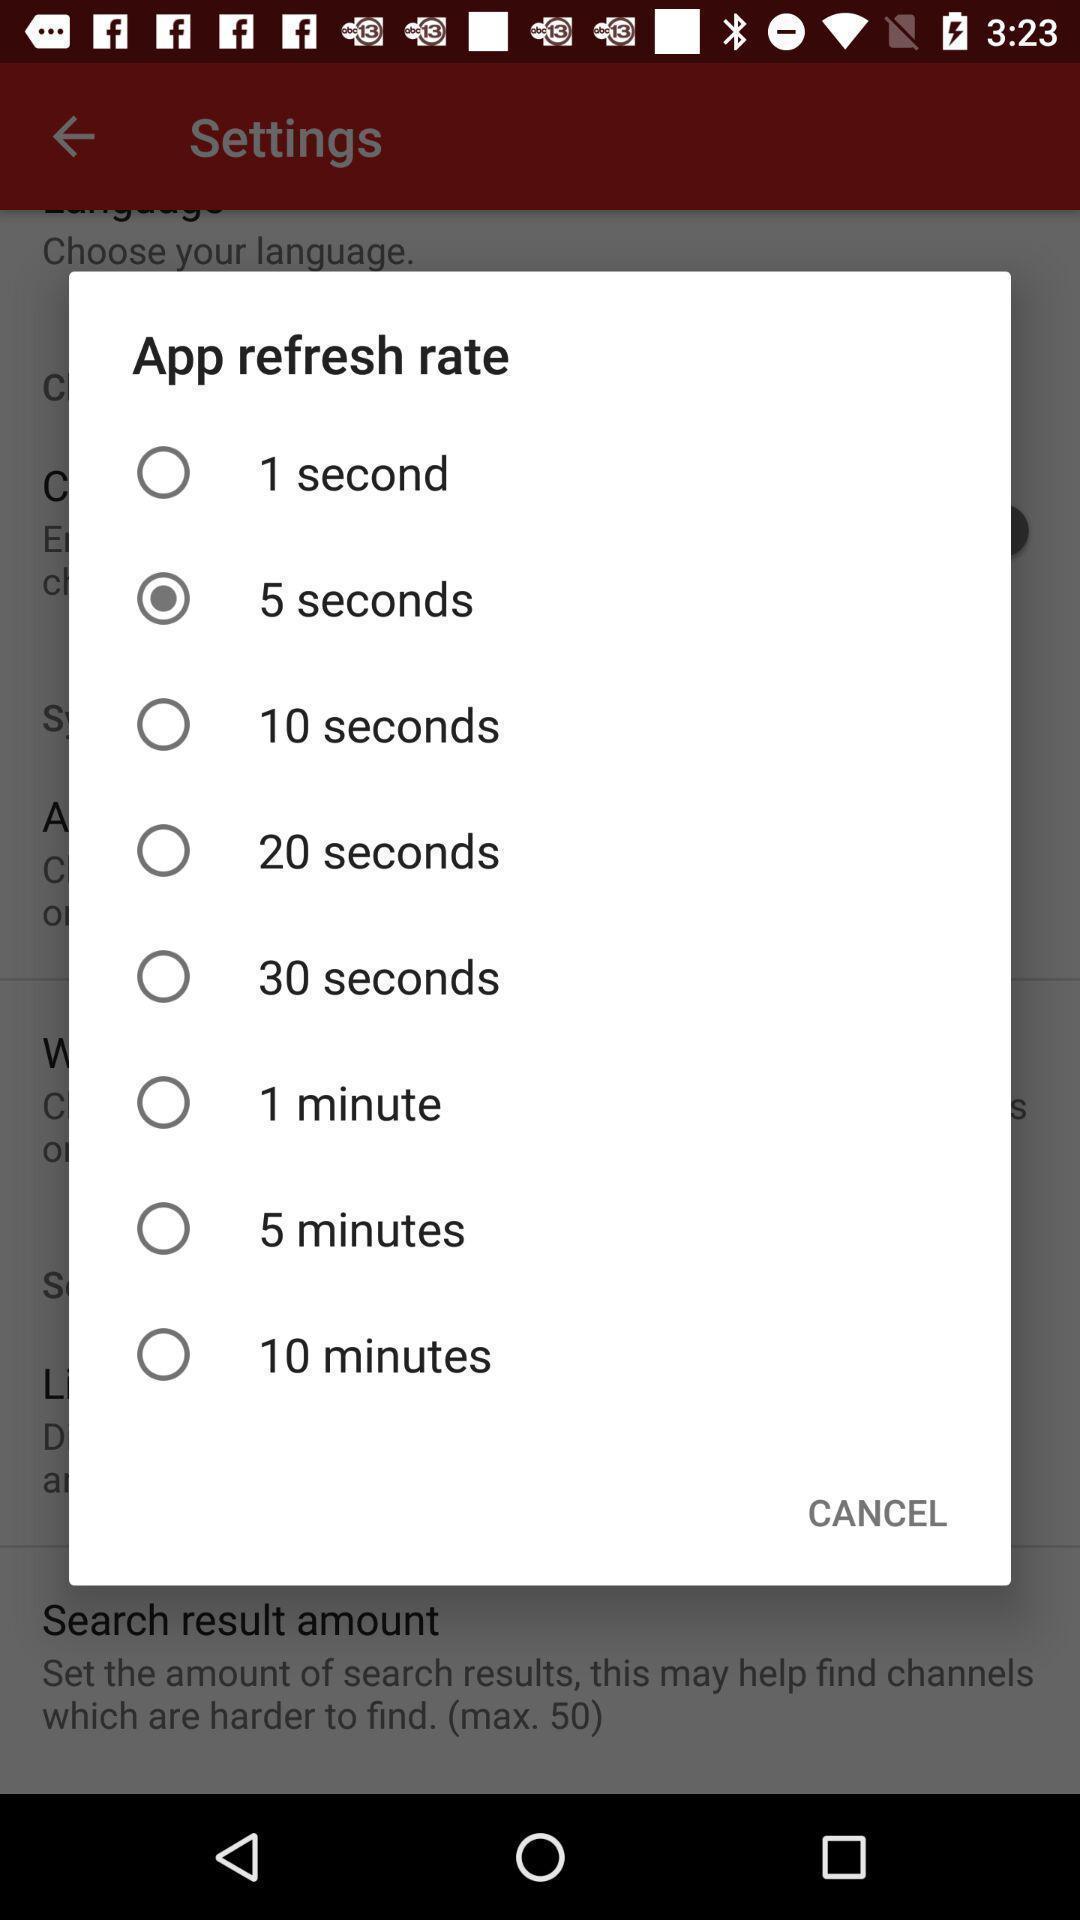What can you discern from this picture? Pop-up displaying time to select. 